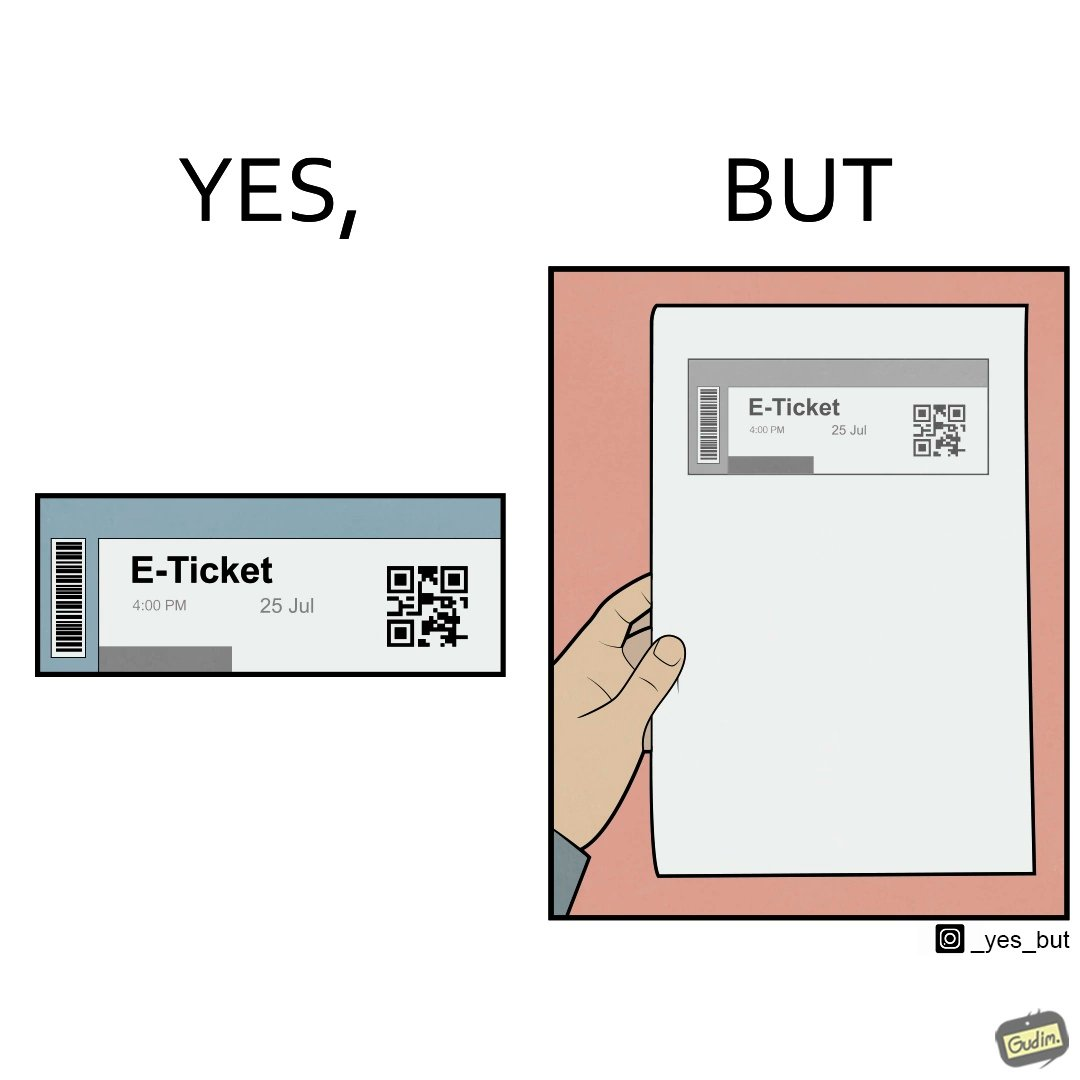Compare the left and right sides of this image. In the left part of the image: It is an e-ticket In the right part of the image: It is an e-ticket printed on paper 